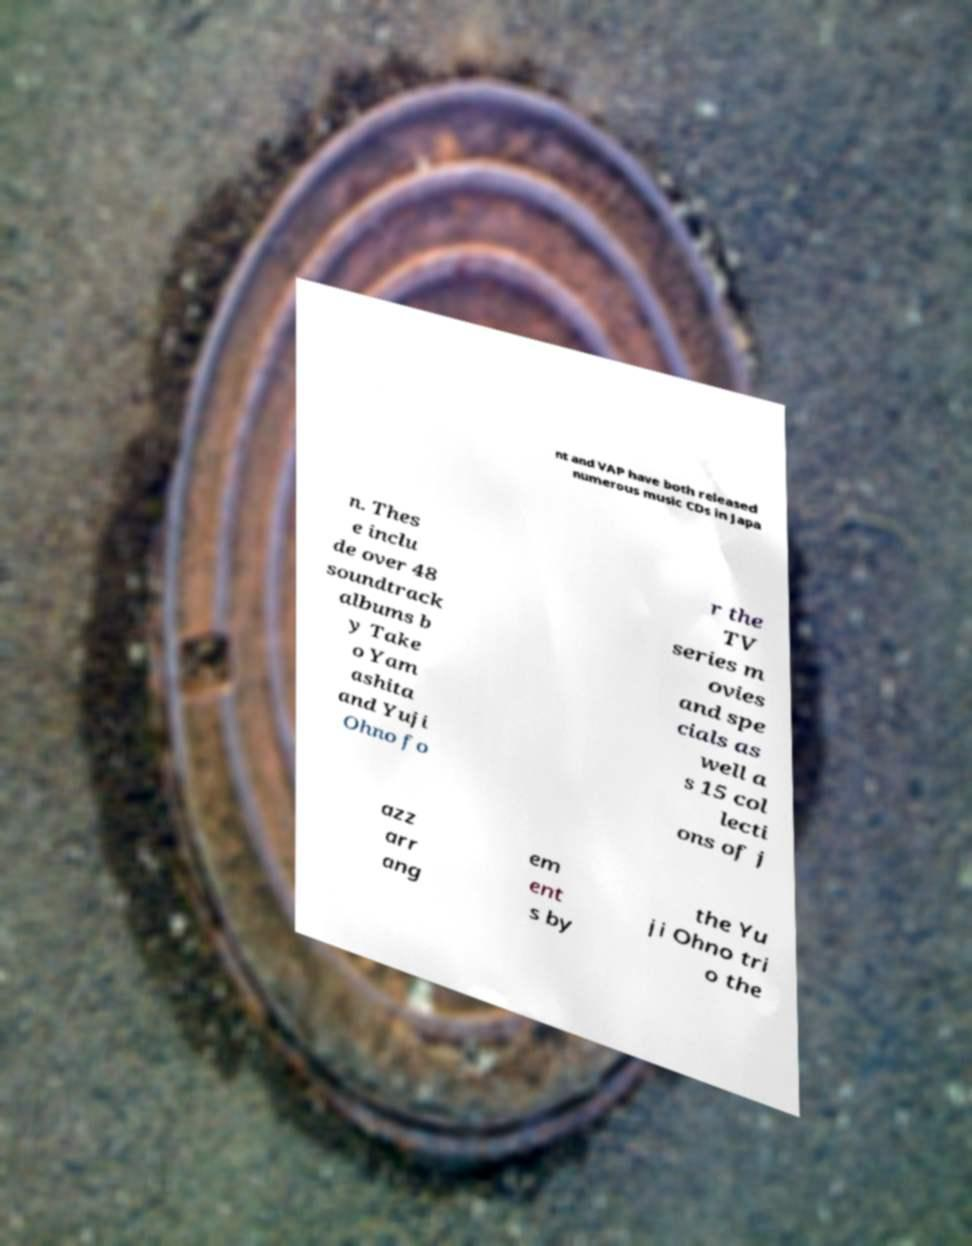I need the written content from this picture converted into text. Can you do that? nt and VAP have both released numerous music CDs in Japa n. Thes e inclu de over 48 soundtrack albums b y Take o Yam ashita and Yuji Ohno fo r the TV series m ovies and spe cials as well a s 15 col lecti ons of j azz arr ang em ent s by the Yu ji Ohno tri o the 